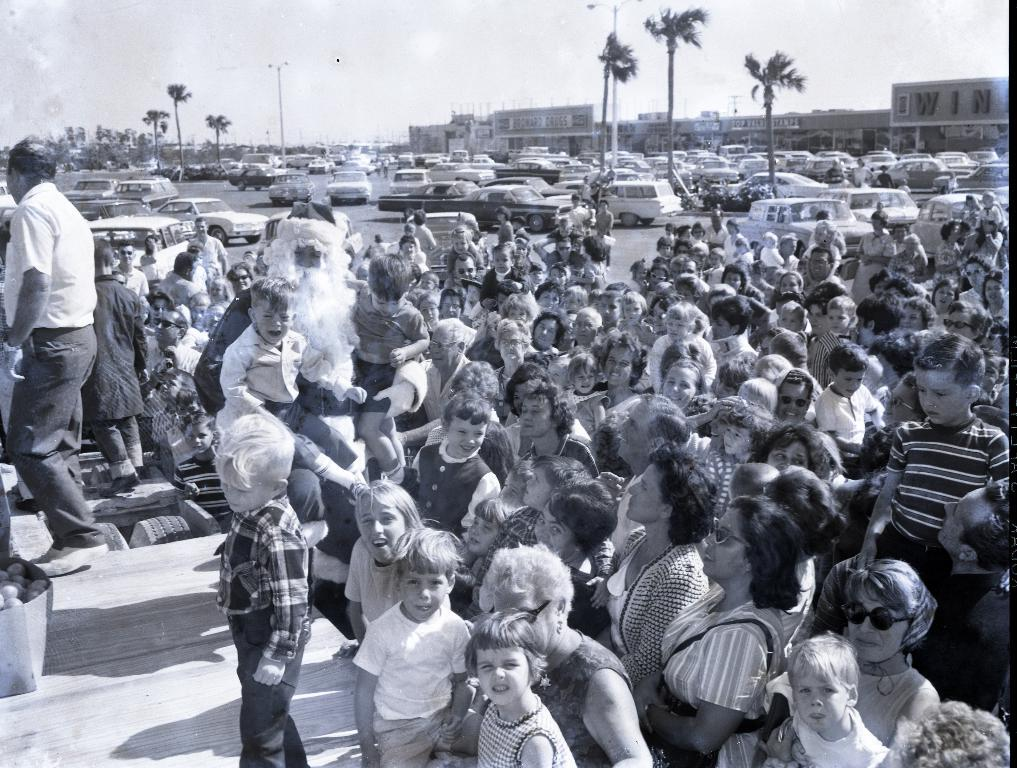What can be seen on the road in the image? There are vehicles on the road in the image. What else is present in the image besides the vehicles? There is a group of people standing in the image, as well as buildings, trees, and the sky visible in the background. Can you see any wood being used by the ants in the image? There are no ants or wood present in the image. Is there a bubble floating in the sky in the image? There is no bubble visible in the sky in the image. 